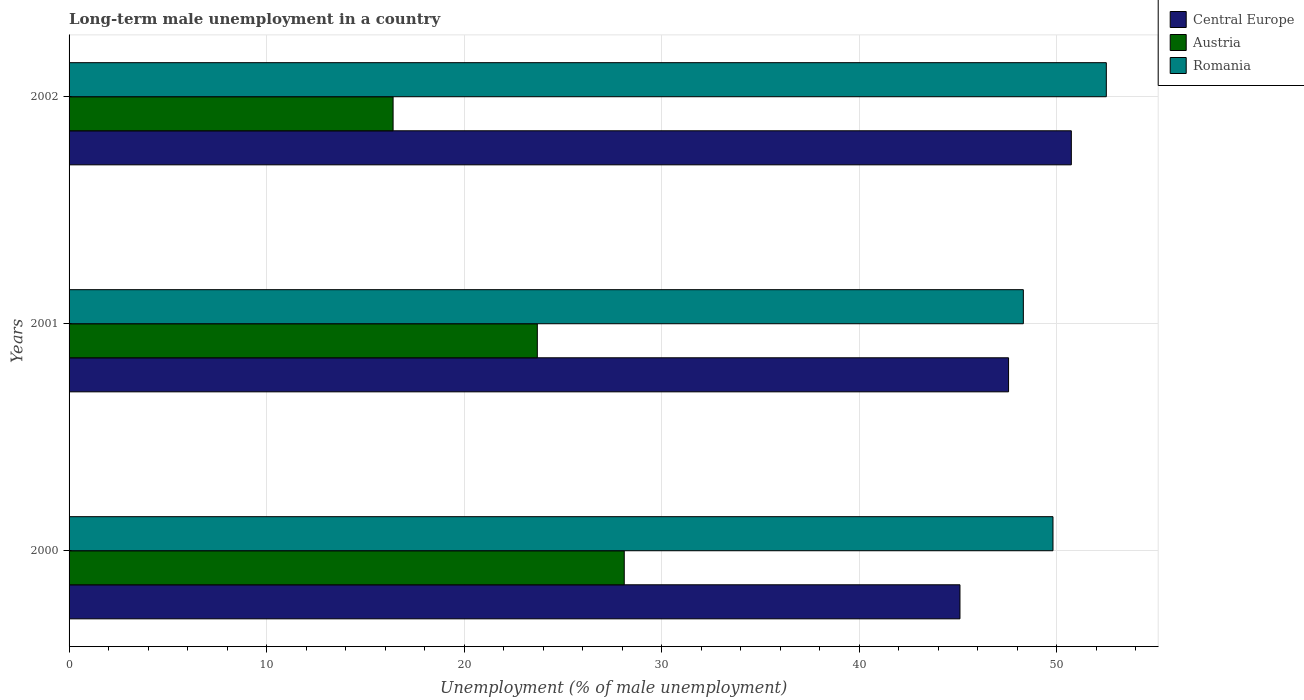How many different coloured bars are there?
Offer a very short reply. 3. How many bars are there on the 1st tick from the top?
Ensure brevity in your answer.  3. What is the label of the 3rd group of bars from the top?
Keep it short and to the point. 2000. What is the percentage of long-term unemployed male population in Romania in 2001?
Provide a succinct answer. 48.3. Across all years, what is the maximum percentage of long-term unemployed male population in Romania?
Your answer should be very brief. 52.5. Across all years, what is the minimum percentage of long-term unemployed male population in Romania?
Your response must be concise. 48.3. In which year was the percentage of long-term unemployed male population in Austria maximum?
Provide a short and direct response. 2000. What is the total percentage of long-term unemployed male population in Romania in the graph?
Offer a terse response. 150.6. What is the difference between the percentage of long-term unemployed male population in Austria in 2000 and that in 2002?
Your response must be concise. 11.7. What is the difference between the percentage of long-term unemployed male population in Central Europe in 2000 and the percentage of long-term unemployed male population in Romania in 2001?
Your answer should be compact. -3.21. What is the average percentage of long-term unemployed male population in Austria per year?
Ensure brevity in your answer.  22.73. In the year 2001, what is the difference between the percentage of long-term unemployed male population in Austria and percentage of long-term unemployed male population in Romania?
Give a very brief answer. -24.6. In how many years, is the percentage of long-term unemployed male population in Romania greater than 24 %?
Offer a terse response. 3. What is the ratio of the percentage of long-term unemployed male population in Austria in 2001 to that in 2002?
Give a very brief answer. 1.45. Is the percentage of long-term unemployed male population in Romania in 2000 less than that in 2001?
Make the answer very short. No. What is the difference between the highest and the second highest percentage of long-term unemployed male population in Austria?
Provide a succinct answer. 4.4. What is the difference between the highest and the lowest percentage of long-term unemployed male population in Central Europe?
Give a very brief answer. 5.64. What does the 3rd bar from the bottom in 2001 represents?
Your response must be concise. Romania. Is it the case that in every year, the sum of the percentage of long-term unemployed male population in Central Europe and percentage of long-term unemployed male population in Romania is greater than the percentage of long-term unemployed male population in Austria?
Your response must be concise. Yes. Does the graph contain any zero values?
Your response must be concise. No. Where does the legend appear in the graph?
Provide a short and direct response. Top right. How many legend labels are there?
Ensure brevity in your answer.  3. How are the legend labels stacked?
Your response must be concise. Vertical. What is the title of the graph?
Your response must be concise. Long-term male unemployment in a country. Does "Greenland" appear as one of the legend labels in the graph?
Give a very brief answer. No. What is the label or title of the X-axis?
Make the answer very short. Unemployment (% of male unemployment). What is the Unemployment (% of male unemployment) in Central Europe in 2000?
Provide a succinct answer. 45.09. What is the Unemployment (% of male unemployment) in Austria in 2000?
Keep it short and to the point. 28.1. What is the Unemployment (% of male unemployment) in Romania in 2000?
Your response must be concise. 49.8. What is the Unemployment (% of male unemployment) in Central Europe in 2001?
Your answer should be very brief. 47.55. What is the Unemployment (% of male unemployment) in Austria in 2001?
Your answer should be compact. 23.7. What is the Unemployment (% of male unemployment) of Romania in 2001?
Your response must be concise. 48.3. What is the Unemployment (% of male unemployment) of Central Europe in 2002?
Provide a short and direct response. 50.73. What is the Unemployment (% of male unemployment) in Austria in 2002?
Offer a terse response. 16.4. What is the Unemployment (% of male unemployment) in Romania in 2002?
Provide a succinct answer. 52.5. Across all years, what is the maximum Unemployment (% of male unemployment) of Central Europe?
Ensure brevity in your answer.  50.73. Across all years, what is the maximum Unemployment (% of male unemployment) in Austria?
Provide a short and direct response. 28.1. Across all years, what is the maximum Unemployment (% of male unemployment) of Romania?
Offer a terse response. 52.5. Across all years, what is the minimum Unemployment (% of male unemployment) in Central Europe?
Give a very brief answer. 45.09. Across all years, what is the minimum Unemployment (% of male unemployment) of Austria?
Make the answer very short. 16.4. Across all years, what is the minimum Unemployment (% of male unemployment) of Romania?
Your answer should be very brief. 48.3. What is the total Unemployment (% of male unemployment) of Central Europe in the graph?
Make the answer very short. 143.37. What is the total Unemployment (% of male unemployment) of Austria in the graph?
Offer a terse response. 68.2. What is the total Unemployment (% of male unemployment) of Romania in the graph?
Give a very brief answer. 150.6. What is the difference between the Unemployment (% of male unemployment) of Central Europe in 2000 and that in 2001?
Your answer should be very brief. -2.46. What is the difference between the Unemployment (% of male unemployment) in Romania in 2000 and that in 2001?
Your response must be concise. 1.5. What is the difference between the Unemployment (% of male unemployment) of Central Europe in 2000 and that in 2002?
Your answer should be very brief. -5.64. What is the difference between the Unemployment (% of male unemployment) in Central Europe in 2001 and that in 2002?
Your response must be concise. -3.18. What is the difference between the Unemployment (% of male unemployment) of Romania in 2001 and that in 2002?
Your answer should be compact. -4.2. What is the difference between the Unemployment (% of male unemployment) of Central Europe in 2000 and the Unemployment (% of male unemployment) of Austria in 2001?
Offer a terse response. 21.39. What is the difference between the Unemployment (% of male unemployment) of Central Europe in 2000 and the Unemployment (% of male unemployment) of Romania in 2001?
Your response must be concise. -3.21. What is the difference between the Unemployment (% of male unemployment) in Austria in 2000 and the Unemployment (% of male unemployment) in Romania in 2001?
Keep it short and to the point. -20.2. What is the difference between the Unemployment (% of male unemployment) in Central Europe in 2000 and the Unemployment (% of male unemployment) in Austria in 2002?
Ensure brevity in your answer.  28.69. What is the difference between the Unemployment (% of male unemployment) in Central Europe in 2000 and the Unemployment (% of male unemployment) in Romania in 2002?
Provide a succinct answer. -7.41. What is the difference between the Unemployment (% of male unemployment) in Austria in 2000 and the Unemployment (% of male unemployment) in Romania in 2002?
Your response must be concise. -24.4. What is the difference between the Unemployment (% of male unemployment) in Central Europe in 2001 and the Unemployment (% of male unemployment) in Austria in 2002?
Your answer should be compact. 31.15. What is the difference between the Unemployment (% of male unemployment) of Central Europe in 2001 and the Unemployment (% of male unemployment) of Romania in 2002?
Your answer should be compact. -4.95. What is the difference between the Unemployment (% of male unemployment) in Austria in 2001 and the Unemployment (% of male unemployment) in Romania in 2002?
Keep it short and to the point. -28.8. What is the average Unemployment (% of male unemployment) of Central Europe per year?
Your answer should be very brief. 47.79. What is the average Unemployment (% of male unemployment) of Austria per year?
Your response must be concise. 22.73. What is the average Unemployment (% of male unemployment) in Romania per year?
Your answer should be compact. 50.2. In the year 2000, what is the difference between the Unemployment (% of male unemployment) in Central Europe and Unemployment (% of male unemployment) in Austria?
Provide a short and direct response. 16.99. In the year 2000, what is the difference between the Unemployment (% of male unemployment) of Central Europe and Unemployment (% of male unemployment) of Romania?
Offer a terse response. -4.71. In the year 2000, what is the difference between the Unemployment (% of male unemployment) in Austria and Unemployment (% of male unemployment) in Romania?
Ensure brevity in your answer.  -21.7. In the year 2001, what is the difference between the Unemployment (% of male unemployment) of Central Europe and Unemployment (% of male unemployment) of Austria?
Keep it short and to the point. 23.85. In the year 2001, what is the difference between the Unemployment (% of male unemployment) in Central Europe and Unemployment (% of male unemployment) in Romania?
Offer a very short reply. -0.75. In the year 2001, what is the difference between the Unemployment (% of male unemployment) of Austria and Unemployment (% of male unemployment) of Romania?
Offer a terse response. -24.6. In the year 2002, what is the difference between the Unemployment (% of male unemployment) of Central Europe and Unemployment (% of male unemployment) of Austria?
Keep it short and to the point. 34.33. In the year 2002, what is the difference between the Unemployment (% of male unemployment) in Central Europe and Unemployment (% of male unemployment) in Romania?
Your answer should be very brief. -1.77. In the year 2002, what is the difference between the Unemployment (% of male unemployment) in Austria and Unemployment (% of male unemployment) in Romania?
Make the answer very short. -36.1. What is the ratio of the Unemployment (% of male unemployment) in Central Europe in 2000 to that in 2001?
Offer a very short reply. 0.95. What is the ratio of the Unemployment (% of male unemployment) in Austria in 2000 to that in 2001?
Offer a very short reply. 1.19. What is the ratio of the Unemployment (% of male unemployment) in Romania in 2000 to that in 2001?
Your response must be concise. 1.03. What is the ratio of the Unemployment (% of male unemployment) of Austria in 2000 to that in 2002?
Provide a short and direct response. 1.71. What is the ratio of the Unemployment (% of male unemployment) in Romania in 2000 to that in 2002?
Your answer should be very brief. 0.95. What is the ratio of the Unemployment (% of male unemployment) of Central Europe in 2001 to that in 2002?
Your answer should be compact. 0.94. What is the ratio of the Unemployment (% of male unemployment) in Austria in 2001 to that in 2002?
Offer a very short reply. 1.45. What is the difference between the highest and the second highest Unemployment (% of male unemployment) in Central Europe?
Offer a terse response. 3.18. What is the difference between the highest and the second highest Unemployment (% of male unemployment) of Austria?
Offer a terse response. 4.4. What is the difference between the highest and the lowest Unemployment (% of male unemployment) in Central Europe?
Your answer should be compact. 5.64. What is the difference between the highest and the lowest Unemployment (% of male unemployment) of Austria?
Provide a short and direct response. 11.7. What is the difference between the highest and the lowest Unemployment (% of male unemployment) in Romania?
Offer a terse response. 4.2. 